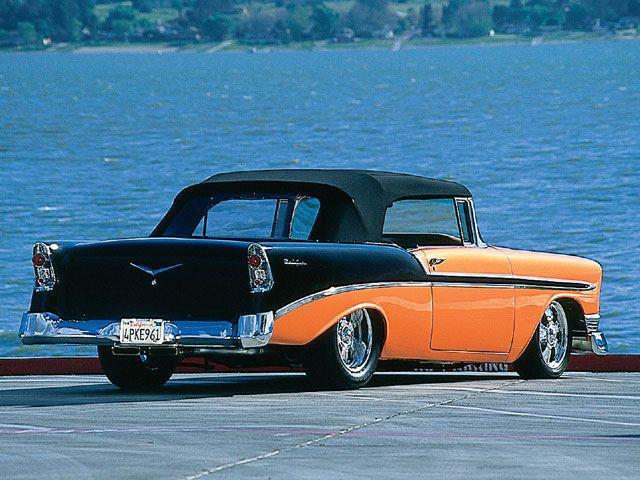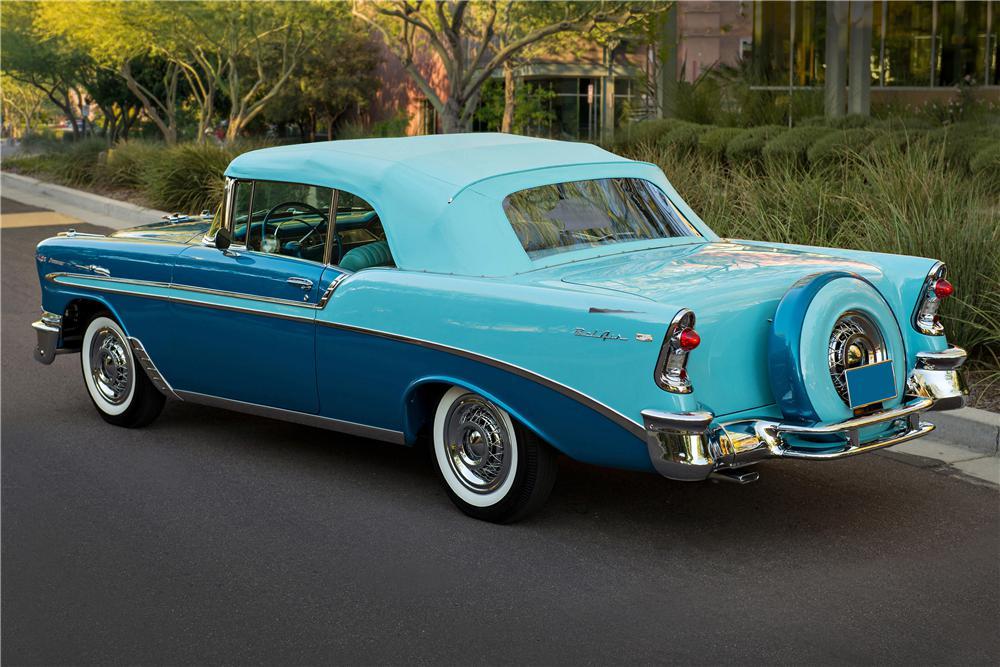The first image is the image on the left, the second image is the image on the right. For the images shown, is this caption "At least one of the cars is parked near the grass." true? Answer yes or no. Yes. 